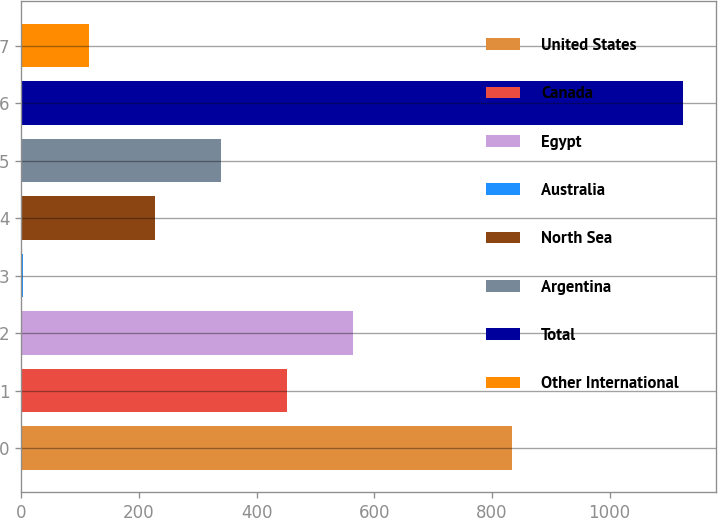Convert chart to OTSL. <chart><loc_0><loc_0><loc_500><loc_500><bar_chart><fcel>United States<fcel>Canada<fcel>Egypt<fcel>Australia<fcel>North Sea<fcel>Argentina<fcel>Total<fcel>Other International<nl><fcel>834.9<fcel>451.68<fcel>563.75<fcel>3.4<fcel>227.54<fcel>339.61<fcel>1124.1<fcel>115.47<nl></chart> 